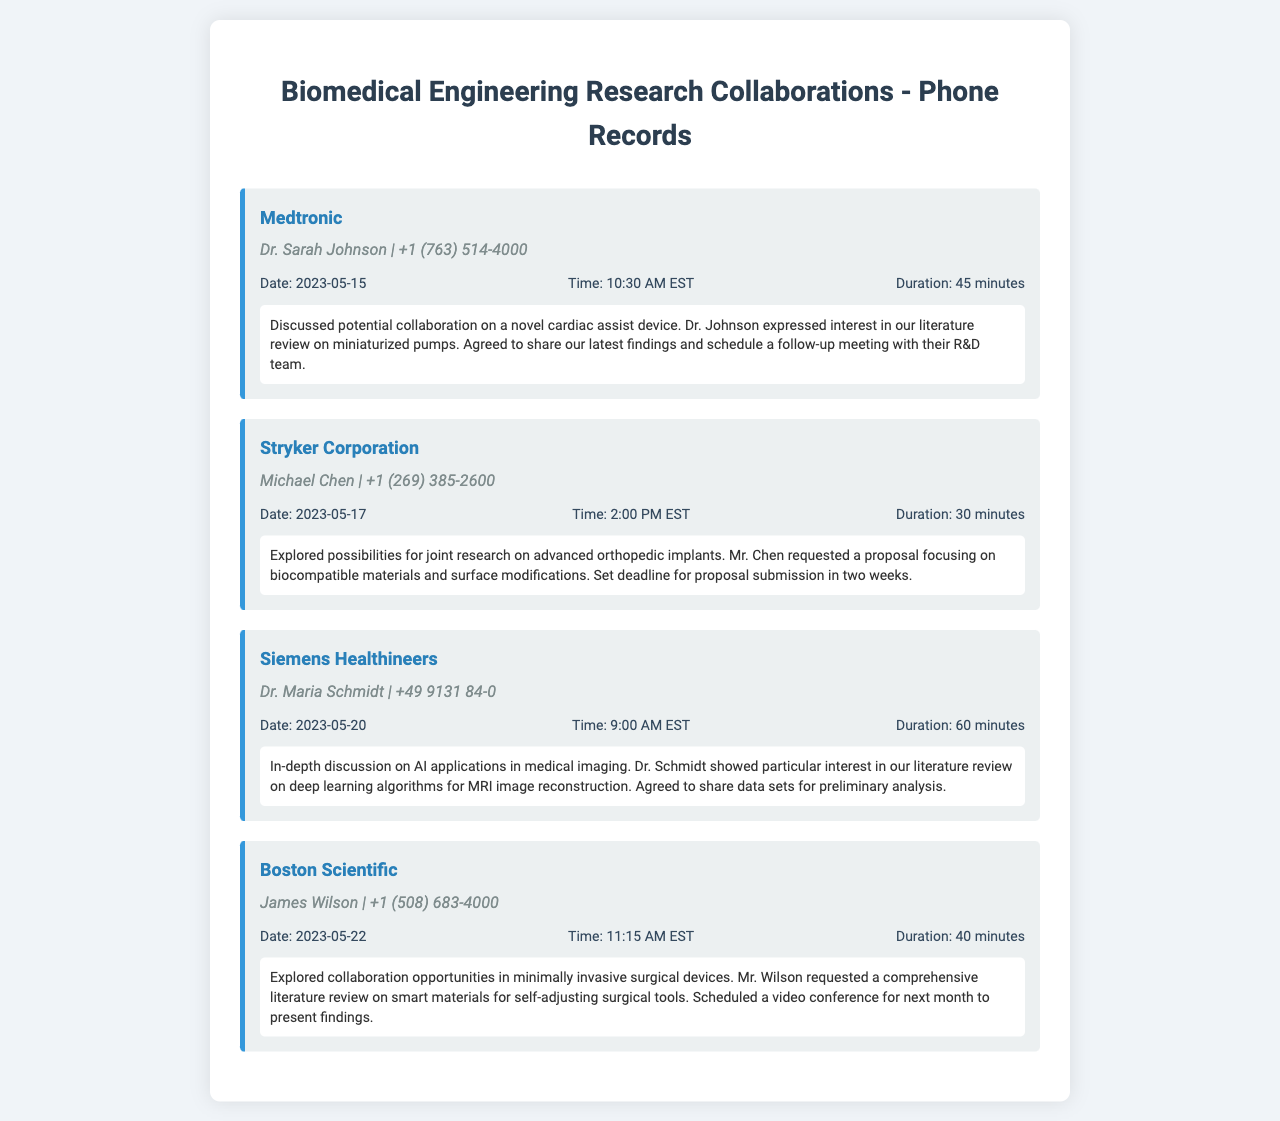What is the name of the first company contacted? The document lists Medtronic as the first company in the phone records.
Answer: Medtronic Who was the contact person at Stryker Corporation? The document provides the name of the contact person, Michael Chen, for Stryker Corporation.
Answer: Michael Chen What was the duration of the call with Siemens Healthineers? The duration mentioned in the document for the call with Siemens Healthineers is 60 minutes.
Answer: 60 minutes On what date did the consultation with Boston Scientific occur? The document states that the consultation with Boston Scientific took place on May 22, 2023.
Answer: 2023-05-22 What topic was discussed with Dr. Sarah Johnson from Medtronic? The document summarizes the discussion topic as a potential collaboration on a novel cardiac assist device.
Answer: novel cardiac assist device How many days after the call with Stryker Corporation was the call with Siemens Healthineers? The dates of the calls can be compared; May 17 to May 20 is a 3-day difference.
Answer: 3 days What specific request did Mr. Wilson from Boston Scientific make? The document states Mr. Wilson requested a comprehensive literature review on smart materials for self-adjusting surgical tools.
Answer: comprehensive literature review Which company’s consultation involved AI applications in medical imaging? The document indicates that Siemens Healthineers was involved in discussions about AI applications in medical imaging.
Answer: Siemens Healthineers What is the agreed action following the call with Medtronic? The document notes the agreed action is to share findings and schedule a follow-up meeting.
Answer: share findings and schedule a follow-up meeting 